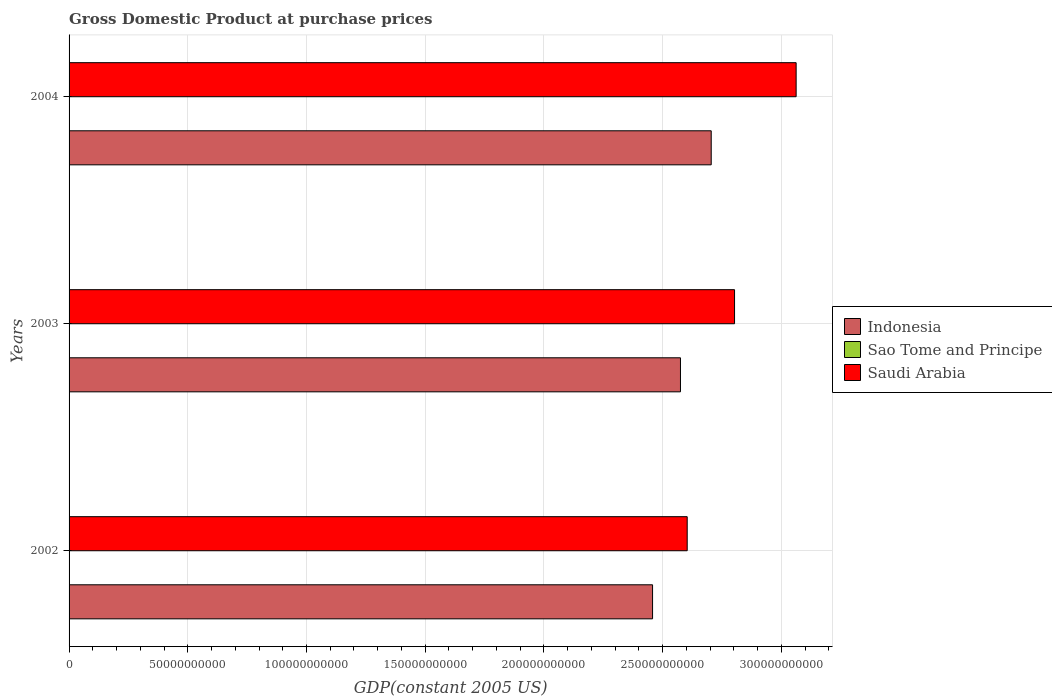How many bars are there on the 1st tick from the bottom?
Offer a terse response. 3. What is the GDP at purchase prices in Saudi Arabia in 2003?
Keep it short and to the point. 2.80e+11. Across all years, what is the maximum GDP at purchase prices in Sao Tome and Principe?
Provide a succinct answer. 1.18e+08. Across all years, what is the minimum GDP at purchase prices in Saudi Arabia?
Provide a succinct answer. 2.60e+11. In which year was the GDP at purchase prices in Indonesia maximum?
Ensure brevity in your answer.  2004. In which year was the GDP at purchase prices in Sao Tome and Principe minimum?
Your answer should be compact. 2002. What is the total GDP at purchase prices in Saudi Arabia in the graph?
Provide a short and direct response. 8.47e+11. What is the difference between the GDP at purchase prices in Sao Tome and Principe in 2002 and that in 2004?
Offer a terse response. -1.13e+07. What is the difference between the GDP at purchase prices in Saudi Arabia in 2003 and the GDP at purchase prices in Indonesia in 2002?
Ensure brevity in your answer.  3.45e+1. What is the average GDP at purchase prices in Indonesia per year?
Your answer should be very brief. 2.58e+11. In the year 2004, what is the difference between the GDP at purchase prices in Sao Tome and Principe and GDP at purchase prices in Indonesia?
Your answer should be very brief. -2.70e+11. In how many years, is the GDP at purchase prices in Indonesia greater than 50000000000 US$?
Your response must be concise. 3. What is the ratio of the GDP at purchase prices in Saudi Arabia in 2003 to that in 2004?
Offer a terse response. 0.92. Is the GDP at purchase prices in Sao Tome and Principe in 2002 less than that in 2004?
Give a very brief answer. Yes. What is the difference between the highest and the second highest GDP at purchase prices in Indonesia?
Make the answer very short. 1.30e+1. What is the difference between the highest and the lowest GDP at purchase prices in Saudi Arabia?
Your response must be concise. 4.59e+1. In how many years, is the GDP at purchase prices in Saudi Arabia greater than the average GDP at purchase prices in Saudi Arabia taken over all years?
Your response must be concise. 1. What does the 1st bar from the top in 2002 represents?
Give a very brief answer. Saudi Arabia. What does the 1st bar from the bottom in 2004 represents?
Provide a succinct answer. Indonesia. Is it the case that in every year, the sum of the GDP at purchase prices in Saudi Arabia and GDP at purchase prices in Sao Tome and Principe is greater than the GDP at purchase prices in Indonesia?
Ensure brevity in your answer.  Yes. Are all the bars in the graph horizontal?
Offer a very short reply. Yes. Does the graph contain grids?
Offer a terse response. Yes. How many legend labels are there?
Provide a short and direct response. 3. How are the legend labels stacked?
Your response must be concise. Vertical. What is the title of the graph?
Provide a succinct answer. Gross Domestic Product at purchase prices. Does "Portugal" appear as one of the legend labels in the graph?
Ensure brevity in your answer.  No. What is the label or title of the X-axis?
Offer a terse response. GDP(constant 2005 US). What is the label or title of the Y-axis?
Offer a very short reply. Years. What is the GDP(constant 2005 US) in Indonesia in 2002?
Your response must be concise. 2.46e+11. What is the GDP(constant 2005 US) of Sao Tome and Principe in 2002?
Your answer should be very brief. 1.06e+08. What is the GDP(constant 2005 US) in Saudi Arabia in 2002?
Your response must be concise. 2.60e+11. What is the GDP(constant 2005 US) in Indonesia in 2003?
Offer a terse response. 2.58e+11. What is the GDP(constant 2005 US) of Sao Tome and Principe in 2003?
Keep it short and to the point. 1.13e+08. What is the GDP(constant 2005 US) in Saudi Arabia in 2003?
Offer a very short reply. 2.80e+11. What is the GDP(constant 2005 US) of Indonesia in 2004?
Your answer should be compact. 2.70e+11. What is the GDP(constant 2005 US) in Sao Tome and Principe in 2004?
Give a very brief answer. 1.18e+08. What is the GDP(constant 2005 US) of Saudi Arabia in 2004?
Offer a terse response. 3.06e+11. Across all years, what is the maximum GDP(constant 2005 US) in Indonesia?
Ensure brevity in your answer.  2.70e+11. Across all years, what is the maximum GDP(constant 2005 US) of Sao Tome and Principe?
Keep it short and to the point. 1.18e+08. Across all years, what is the maximum GDP(constant 2005 US) of Saudi Arabia?
Provide a succinct answer. 3.06e+11. Across all years, what is the minimum GDP(constant 2005 US) of Indonesia?
Provide a succinct answer. 2.46e+11. Across all years, what is the minimum GDP(constant 2005 US) in Sao Tome and Principe?
Give a very brief answer. 1.06e+08. Across all years, what is the minimum GDP(constant 2005 US) of Saudi Arabia?
Ensure brevity in your answer.  2.60e+11. What is the total GDP(constant 2005 US) in Indonesia in the graph?
Provide a succinct answer. 7.74e+11. What is the total GDP(constant 2005 US) of Sao Tome and Principe in the graph?
Give a very brief answer. 3.38e+08. What is the total GDP(constant 2005 US) of Saudi Arabia in the graph?
Provide a short and direct response. 8.47e+11. What is the difference between the GDP(constant 2005 US) in Indonesia in 2002 and that in 2003?
Keep it short and to the point. -1.17e+1. What is the difference between the GDP(constant 2005 US) of Sao Tome and Principe in 2002 and that in 2003?
Your answer should be compact. -7.00e+06. What is the difference between the GDP(constant 2005 US) in Saudi Arabia in 2002 and that in 2003?
Offer a very short reply. -1.99e+1. What is the difference between the GDP(constant 2005 US) in Indonesia in 2002 and that in 2004?
Provide a short and direct response. -2.47e+1. What is the difference between the GDP(constant 2005 US) of Sao Tome and Principe in 2002 and that in 2004?
Offer a very short reply. -1.13e+07. What is the difference between the GDP(constant 2005 US) of Saudi Arabia in 2002 and that in 2004?
Ensure brevity in your answer.  -4.59e+1. What is the difference between the GDP(constant 2005 US) of Indonesia in 2003 and that in 2004?
Make the answer very short. -1.30e+1. What is the difference between the GDP(constant 2005 US) of Sao Tome and Principe in 2003 and that in 2004?
Your answer should be very brief. -4.35e+06. What is the difference between the GDP(constant 2005 US) of Saudi Arabia in 2003 and that in 2004?
Offer a terse response. -2.59e+1. What is the difference between the GDP(constant 2005 US) in Indonesia in 2002 and the GDP(constant 2005 US) in Sao Tome and Principe in 2003?
Make the answer very short. 2.46e+11. What is the difference between the GDP(constant 2005 US) in Indonesia in 2002 and the GDP(constant 2005 US) in Saudi Arabia in 2003?
Ensure brevity in your answer.  -3.45e+1. What is the difference between the GDP(constant 2005 US) of Sao Tome and Principe in 2002 and the GDP(constant 2005 US) of Saudi Arabia in 2003?
Your answer should be very brief. -2.80e+11. What is the difference between the GDP(constant 2005 US) of Indonesia in 2002 and the GDP(constant 2005 US) of Sao Tome and Principe in 2004?
Provide a short and direct response. 2.46e+11. What is the difference between the GDP(constant 2005 US) in Indonesia in 2002 and the GDP(constant 2005 US) in Saudi Arabia in 2004?
Offer a terse response. -6.05e+1. What is the difference between the GDP(constant 2005 US) in Sao Tome and Principe in 2002 and the GDP(constant 2005 US) in Saudi Arabia in 2004?
Offer a very short reply. -3.06e+11. What is the difference between the GDP(constant 2005 US) in Indonesia in 2003 and the GDP(constant 2005 US) in Sao Tome and Principe in 2004?
Provide a short and direct response. 2.57e+11. What is the difference between the GDP(constant 2005 US) of Indonesia in 2003 and the GDP(constant 2005 US) of Saudi Arabia in 2004?
Your answer should be compact. -4.87e+1. What is the difference between the GDP(constant 2005 US) of Sao Tome and Principe in 2003 and the GDP(constant 2005 US) of Saudi Arabia in 2004?
Make the answer very short. -3.06e+11. What is the average GDP(constant 2005 US) of Indonesia per year?
Ensure brevity in your answer.  2.58e+11. What is the average GDP(constant 2005 US) in Sao Tome and Principe per year?
Your answer should be compact. 1.13e+08. What is the average GDP(constant 2005 US) in Saudi Arabia per year?
Ensure brevity in your answer.  2.82e+11. In the year 2002, what is the difference between the GDP(constant 2005 US) of Indonesia and GDP(constant 2005 US) of Sao Tome and Principe?
Offer a very short reply. 2.46e+11. In the year 2002, what is the difference between the GDP(constant 2005 US) in Indonesia and GDP(constant 2005 US) in Saudi Arabia?
Provide a succinct answer. -1.46e+1. In the year 2002, what is the difference between the GDP(constant 2005 US) in Sao Tome and Principe and GDP(constant 2005 US) in Saudi Arabia?
Provide a succinct answer. -2.60e+11. In the year 2003, what is the difference between the GDP(constant 2005 US) of Indonesia and GDP(constant 2005 US) of Sao Tome and Principe?
Keep it short and to the point. 2.57e+11. In the year 2003, what is the difference between the GDP(constant 2005 US) in Indonesia and GDP(constant 2005 US) in Saudi Arabia?
Provide a succinct answer. -2.28e+1. In the year 2003, what is the difference between the GDP(constant 2005 US) of Sao Tome and Principe and GDP(constant 2005 US) of Saudi Arabia?
Your answer should be very brief. -2.80e+11. In the year 2004, what is the difference between the GDP(constant 2005 US) in Indonesia and GDP(constant 2005 US) in Sao Tome and Principe?
Make the answer very short. 2.70e+11. In the year 2004, what is the difference between the GDP(constant 2005 US) in Indonesia and GDP(constant 2005 US) in Saudi Arabia?
Offer a very short reply. -3.58e+1. In the year 2004, what is the difference between the GDP(constant 2005 US) in Sao Tome and Principe and GDP(constant 2005 US) in Saudi Arabia?
Your answer should be very brief. -3.06e+11. What is the ratio of the GDP(constant 2005 US) of Indonesia in 2002 to that in 2003?
Offer a terse response. 0.95. What is the ratio of the GDP(constant 2005 US) in Sao Tome and Principe in 2002 to that in 2003?
Your response must be concise. 0.94. What is the ratio of the GDP(constant 2005 US) of Saudi Arabia in 2002 to that in 2003?
Offer a very short reply. 0.93. What is the ratio of the GDP(constant 2005 US) in Indonesia in 2002 to that in 2004?
Give a very brief answer. 0.91. What is the ratio of the GDP(constant 2005 US) of Sao Tome and Principe in 2002 to that in 2004?
Provide a short and direct response. 0.9. What is the ratio of the GDP(constant 2005 US) of Saudi Arabia in 2002 to that in 2004?
Offer a terse response. 0.85. What is the ratio of the GDP(constant 2005 US) in Indonesia in 2003 to that in 2004?
Ensure brevity in your answer.  0.95. What is the ratio of the GDP(constant 2005 US) in Sao Tome and Principe in 2003 to that in 2004?
Ensure brevity in your answer.  0.96. What is the ratio of the GDP(constant 2005 US) of Saudi Arabia in 2003 to that in 2004?
Your response must be concise. 0.92. What is the difference between the highest and the second highest GDP(constant 2005 US) in Indonesia?
Provide a succinct answer. 1.30e+1. What is the difference between the highest and the second highest GDP(constant 2005 US) of Sao Tome and Principe?
Ensure brevity in your answer.  4.35e+06. What is the difference between the highest and the second highest GDP(constant 2005 US) in Saudi Arabia?
Your answer should be very brief. 2.59e+1. What is the difference between the highest and the lowest GDP(constant 2005 US) of Indonesia?
Offer a very short reply. 2.47e+1. What is the difference between the highest and the lowest GDP(constant 2005 US) of Sao Tome and Principe?
Offer a very short reply. 1.13e+07. What is the difference between the highest and the lowest GDP(constant 2005 US) in Saudi Arabia?
Offer a terse response. 4.59e+1. 